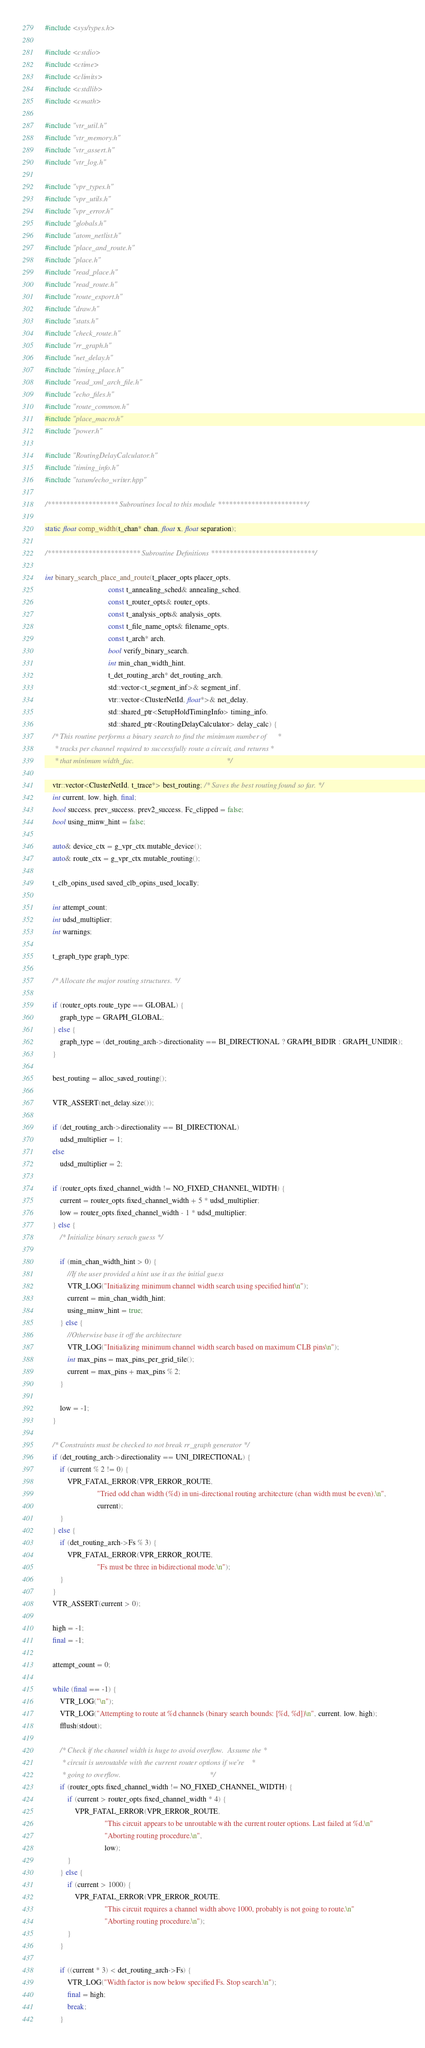<code> <loc_0><loc_0><loc_500><loc_500><_C++_>#include <sys/types.h>

#include <cstdio>
#include <ctime>
#include <climits>
#include <cstdlib>
#include <cmath>

#include "vtr_util.h"
#include "vtr_memory.h"
#include "vtr_assert.h"
#include "vtr_log.h"

#include "vpr_types.h"
#include "vpr_utils.h"
#include "vpr_error.h"
#include "globals.h"
#include "atom_netlist.h"
#include "place_and_route.h"
#include "place.h"
#include "read_place.h"
#include "read_route.h"
#include "route_export.h"
#include "draw.h"
#include "stats.h"
#include "check_route.h"
#include "rr_graph.h"
#include "net_delay.h"
#include "timing_place.h"
#include "read_xml_arch_file.h"
#include "echo_files.h"
#include "route_common.h"
#include "place_macro.h"
#include "power.h"

#include "RoutingDelayCalculator.h"
#include "timing_info.h"
#include "tatum/echo_writer.hpp"

/******************* Subroutines local to this module ************************/

static float comp_width(t_chan* chan, float x, float separation);

/************************* Subroutine Definitions ****************************/

int binary_search_place_and_route(t_placer_opts placer_opts,
                                  const t_annealing_sched& annealing_sched,
                                  const t_router_opts& router_opts,
                                  const t_analysis_opts& analysis_opts,
                                  const t_file_name_opts& filename_opts,
                                  const t_arch* arch,
                                  bool verify_binary_search,
                                  int min_chan_width_hint,
                                  t_det_routing_arch* det_routing_arch,
                                  std::vector<t_segment_inf>& segment_inf,
                                  vtr::vector<ClusterNetId, float*>& net_delay,
                                  std::shared_ptr<SetupHoldTimingInfo> timing_info,
                                  std::shared_ptr<RoutingDelayCalculator> delay_calc) {
    /* This routine performs a binary search to find the minimum number of      *
     * tracks per channel required to successfully route a circuit, and returns *
     * that minimum width_fac.                                                  */

    vtr::vector<ClusterNetId, t_trace*> best_routing; /* Saves the best routing found so far. */
    int current, low, high, final;
    bool success, prev_success, prev2_success, Fc_clipped = false;
    bool using_minw_hint = false;

    auto& device_ctx = g_vpr_ctx.mutable_device();
    auto& route_ctx = g_vpr_ctx.mutable_routing();

    t_clb_opins_used saved_clb_opins_used_locally;

    int attempt_count;
    int udsd_multiplier;
    int warnings;

    t_graph_type graph_type;

    /* Allocate the major routing structures. */

    if (router_opts.route_type == GLOBAL) {
        graph_type = GRAPH_GLOBAL;
    } else {
        graph_type = (det_routing_arch->directionality == BI_DIRECTIONAL ? GRAPH_BIDIR : GRAPH_UNIDIR);
    }

    best_routing = alloc_saved_routing();

    VTR_ASSERT(net_delay.size());

    if (det_routing_arch->directionality == BI_DIRECTIONAL)
        udsd_multiplier = 1;
    else
        udsd_multiplier = 2;

    if (router_opts.fixed_channel_width != NO_FIXED_CHANNEL_WIDTH) {
        current = router_opts.fixed_channel_width + 5 * udsd_multiplier;
        low = router_opts.fixed_channel_width - 1 * udsd_multiplier;
    } else {
        /* Initialize binary serach guess */

        if (min_chan_width_hint > 0) {
            //If the user provided a hint use it as the initial guess
            VTR_LOG("Initializing minimum channel width search using specified hint\n");
            current = min_chan_width_hint;
            using_minw_hint = true;
        } else {
            //Otherwise base it off the architecture
            VTR_LOG("Initializing minimum channel width search based on maximum CLB pins\n");
            int max_pins = max_pins_per_grid_tile();
            current = max_pins + max_pins % 2;
        }

        low = -1;
    }

    /* Constraints must be checked to not break rr_graph generator */
    if (det_routing_arch->directionality == UNI_DIRECTIONAL) {
        if (current % 2 != 0) {
            VPR_FATAL_ERROR(VPR_ERROR_ROUTE,
                            "Tried odd chan width (%d) in uni-directional routing architecture (chan width must be even).\n",
                            current);
        }
    } else {
        if (det_routing_arch->Fs % 3) {
            VPR_FATAL_ERROR(VPR_ERROR_ROUTE,
                            "Fs must be three in bidirectional mode.\n");
        }
    }
    VTR_ASSERT(current > 0);

    high = -1;
    final = -1;

    attempt_count = 0;

    while (final == -1) {
        VTR_LOG("\n");
        VTR_LOG("Attempting to route at %d channels (binary search bounds: [%d, %d])\n", current, low, high);
        fflush(stdout);

        /* Check if the channel width is huge to avoid overflow.  Assume the *
         * circuit is unroutable with the current router options if we're    *
         * going to overflow.                                                */
        if (router_opts.fixed_channel_width != NO_FIXED_CHANNEL_WIDTH) {
            if (current > router_opts.fixed_channel_width * 4) {
                VPR_FATAL_ERROR(VPR_ERROR_ROUTE,
                                "This circuit appears to be unroutable with the current router options. Last failed at %d.\n"
                                "Aborting routing procedure.\n",
                                low);
            }
        } else {
            if (current > 1000) {
                VPR_FATAL_ERROR(VPR_ERROR_ROUTE,
                                "This circuit requires a channel width above 1000, probably is not going to route.\n"
                                "Aborting routing procedure.\n");
            }
        }

        if ((current * 3) < det_routing_arch->Fs) {
            VTR_LOG("Width factor is now below specified Fs. Stop search.\n");
            final = high;
            break;
        }
</code> 